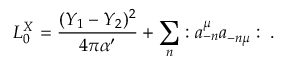<formula> <loc_0><loc_0><loc_500><loc_500>L _ { 0 } ^ { X } = { \frac { ( Y _ { 1 } - Y _ { 2 } ) ^ { 2 } } { 4 \pi \alpha ^ { \prime } } } + \sum _ { n } \colon a _ { - n } ^ { \mu } a _ { - n \mu } \colon \, .</formula> 